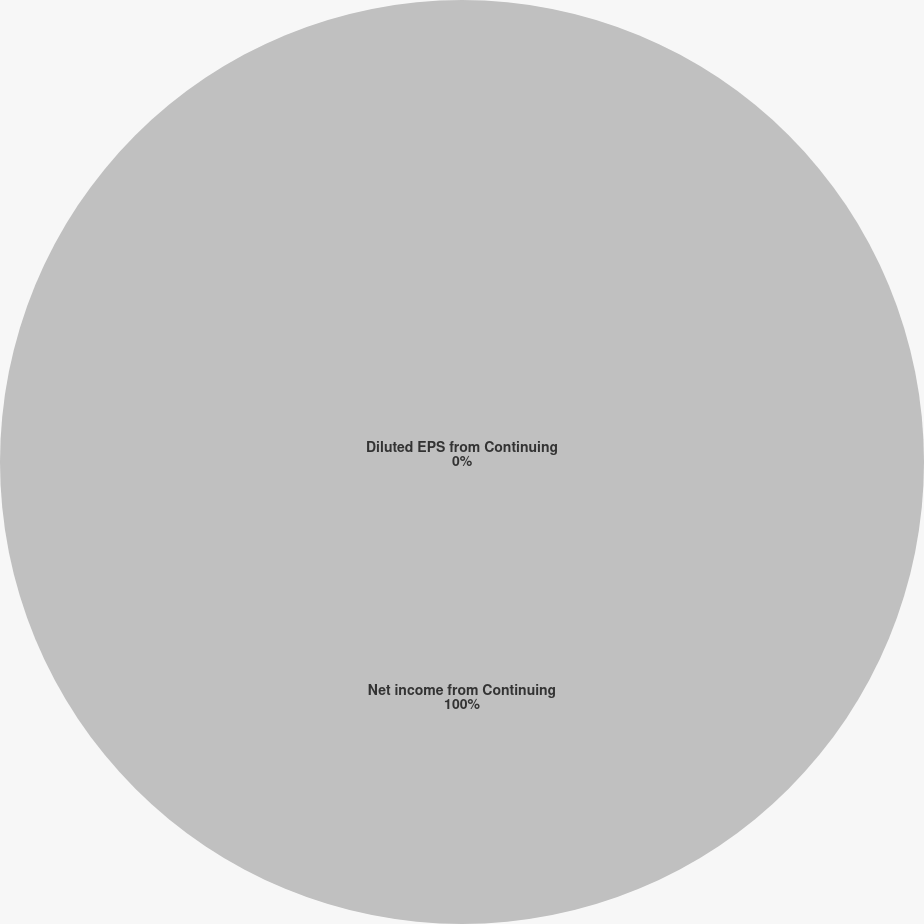Convert chart to OTSL. <chart><loc_0><loc_0><loc_500><loc_500><pie_chart><fcel>Net income from Continuing<fcel>Diluted EPS from Continuing<nl><fcel>100.0%<fcel>0.0%<nl></chart> 